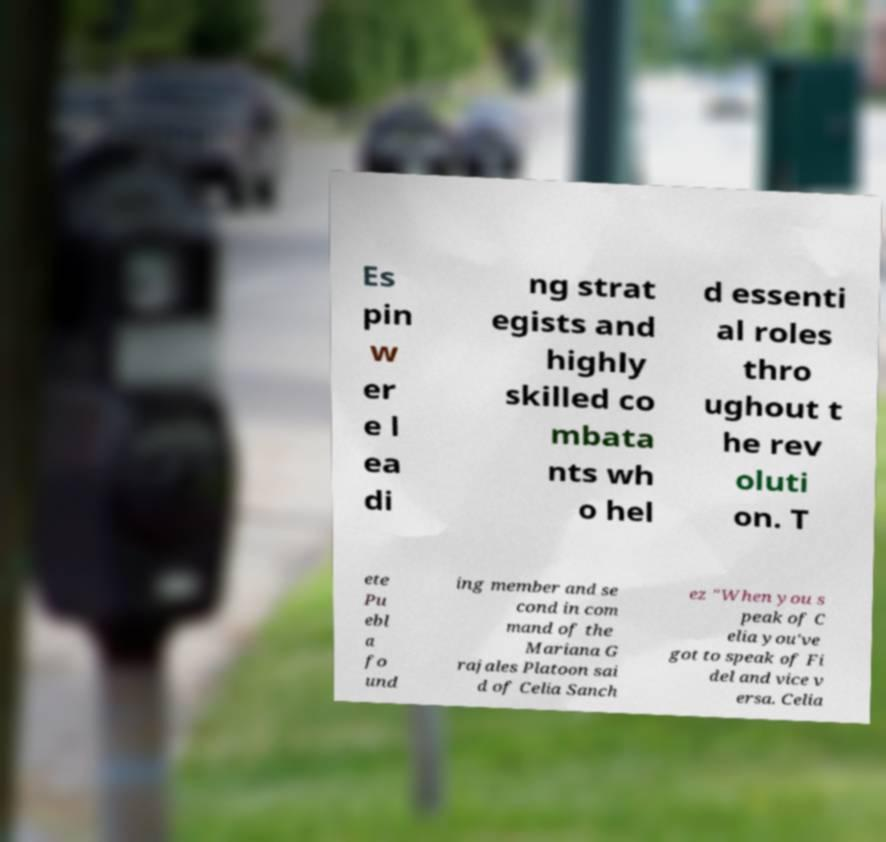For documentation purposes, I need the text within this image transcribed. Could you provide that? Es pin w er e l ea di ng strat egists and highly skilled co mbata nts wh o hel d essenti al roles thro ughout t he rev oluti on. T ete Pu ebl a fo und ing member and se cond in com mand of the Mariana G rajales Platoon sai d of Celia Sanch ez "When you s peak of C elia you've got to speak of Fi del and vice v ersa. Celia 